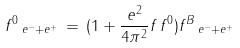<formula> <loc_0><loc_0><loc_500><loc_500>f ^ { 0 } \, _ { e ^ { - } + e ^ { + } } \, = \, ( 1 + \frac { e ^ { 2 } } { 4 \pi ^ { 2 } } f \, f ^ { 0 } ) f ^ { B } \, _ { e ^ { - } + e ^ { + } }</formula> 